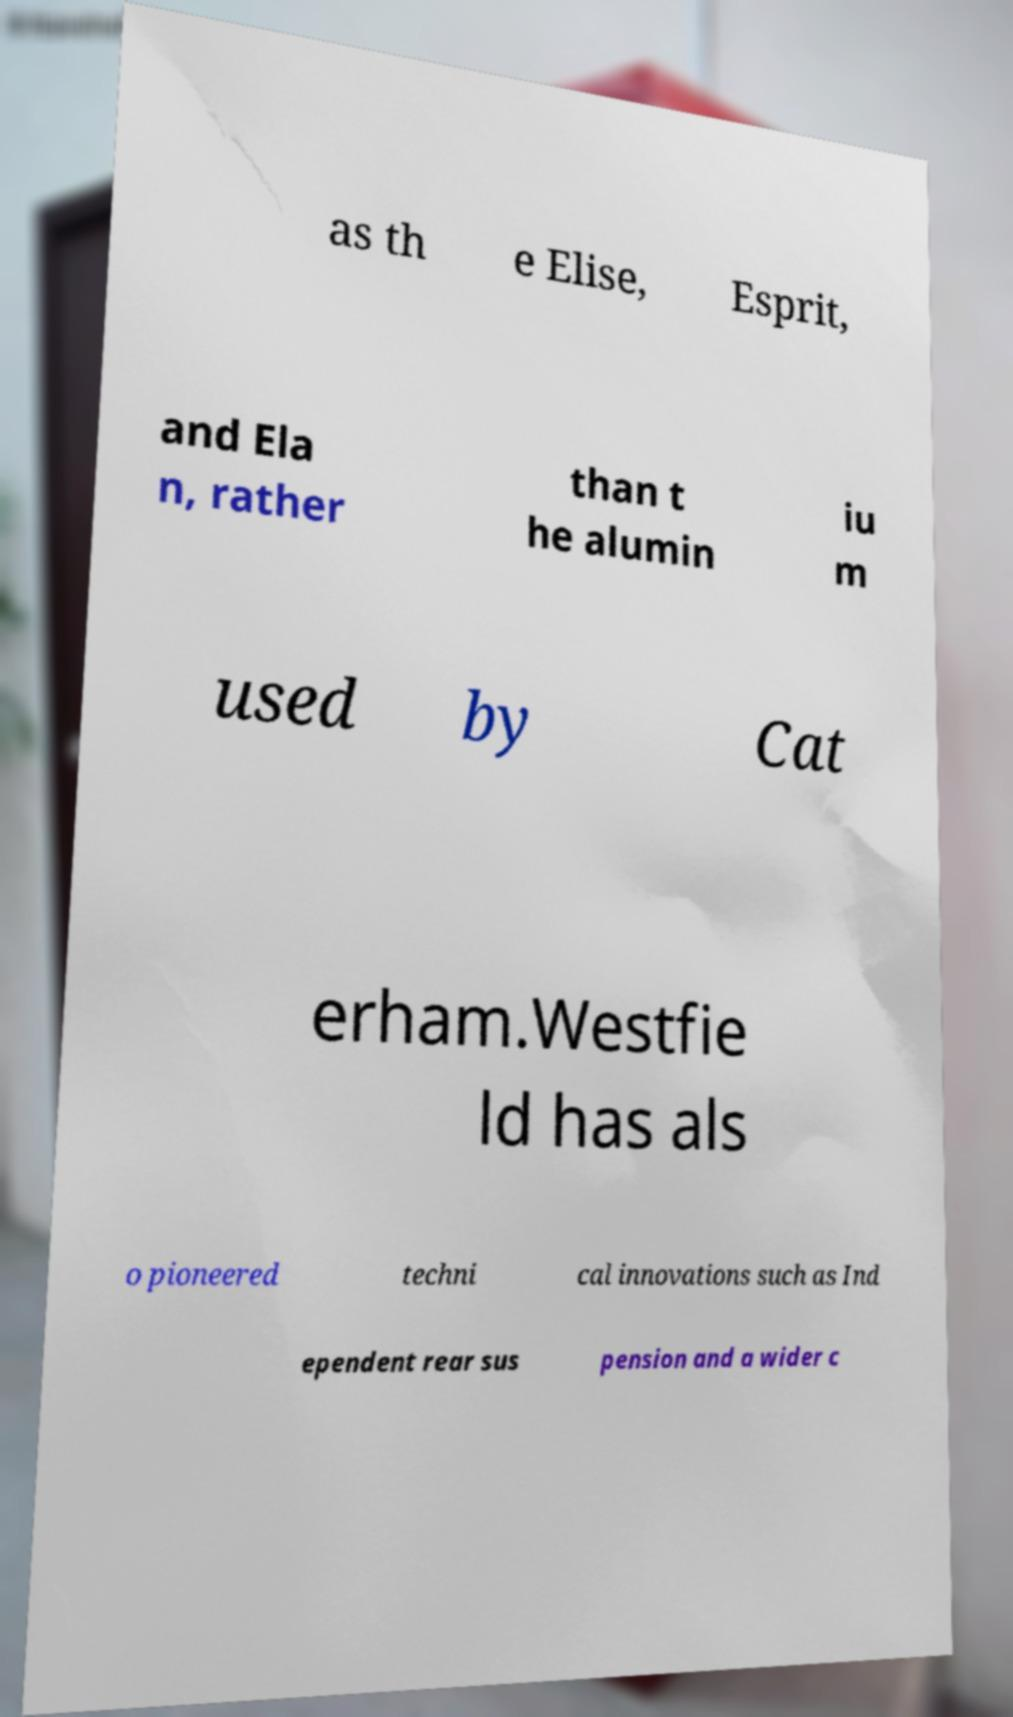What messages or text are displayed in this image? I need them in a readable, typed format. as th e Elise, Esprit, and Ela n, rather than t he alumin iu m used by Cat erham.Westfie ld has als o pioneered techni cal innovations such as Ind ependent rear sus pension and a wider c 